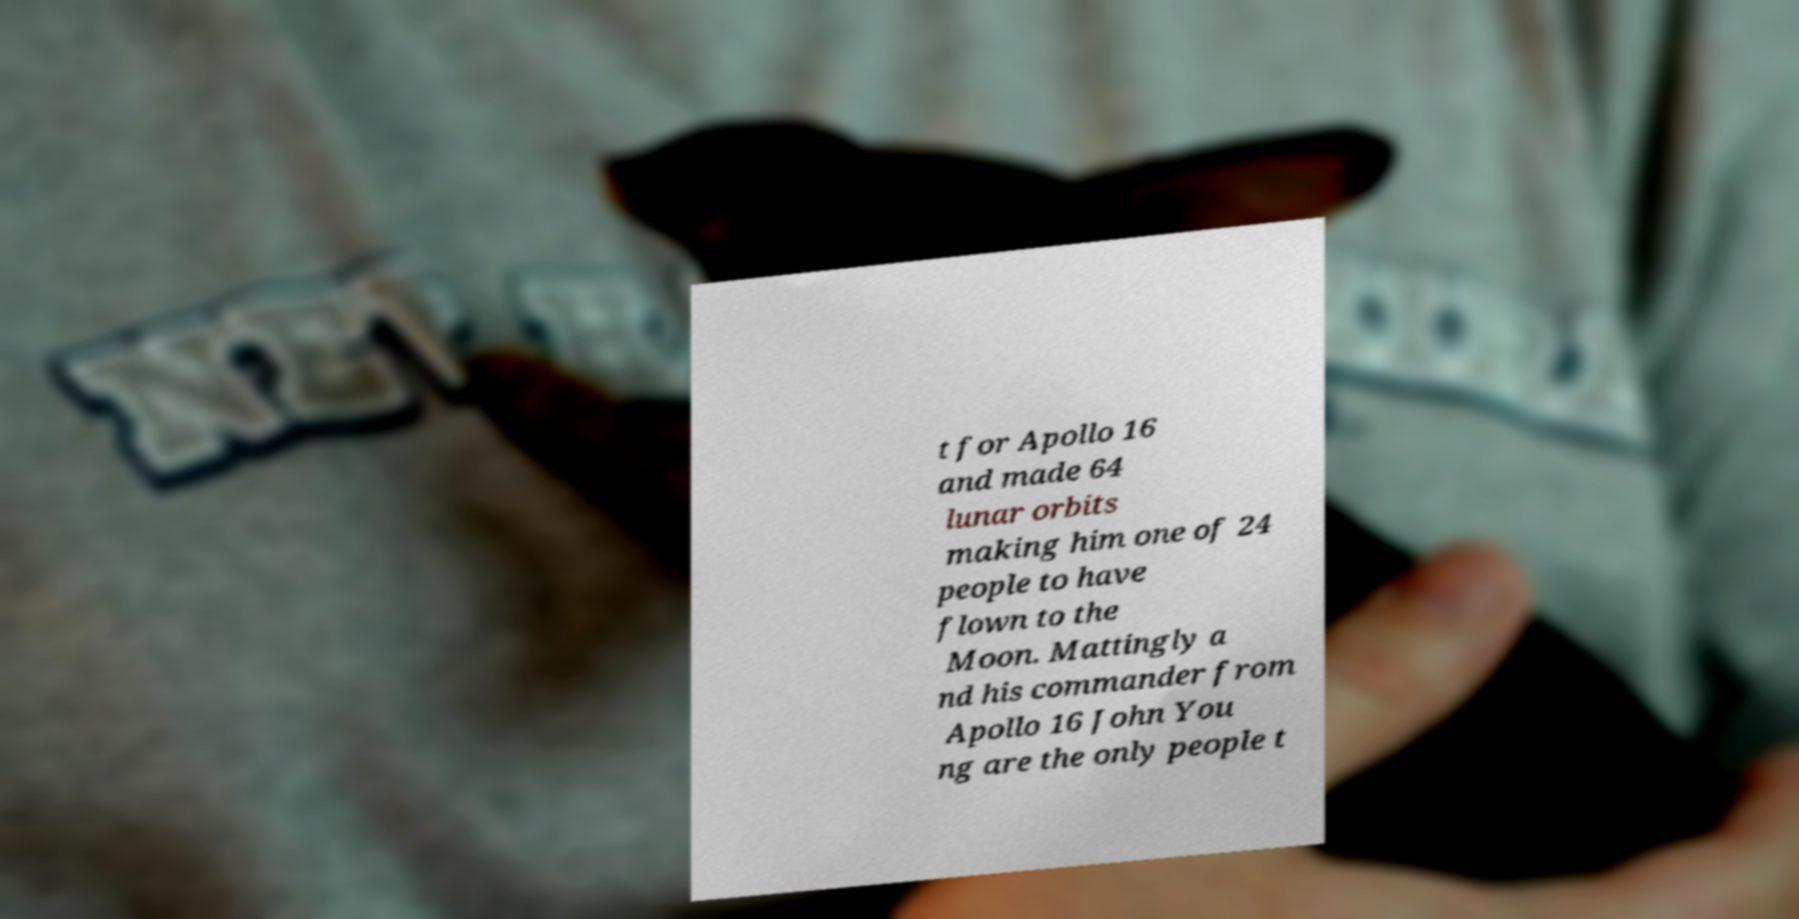Could you assist in decoding the text presented in this image and type it out clearly? t for Apollo 16 and made 64 lunar orbits making him one of 24 people to have flown to the Moon. Mattingly a nd his commander from Apollo 16 John You ng are the only people t 